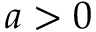<formula> <loc_0><loc_0><loc_500><loc_500>a > 0</formula> 